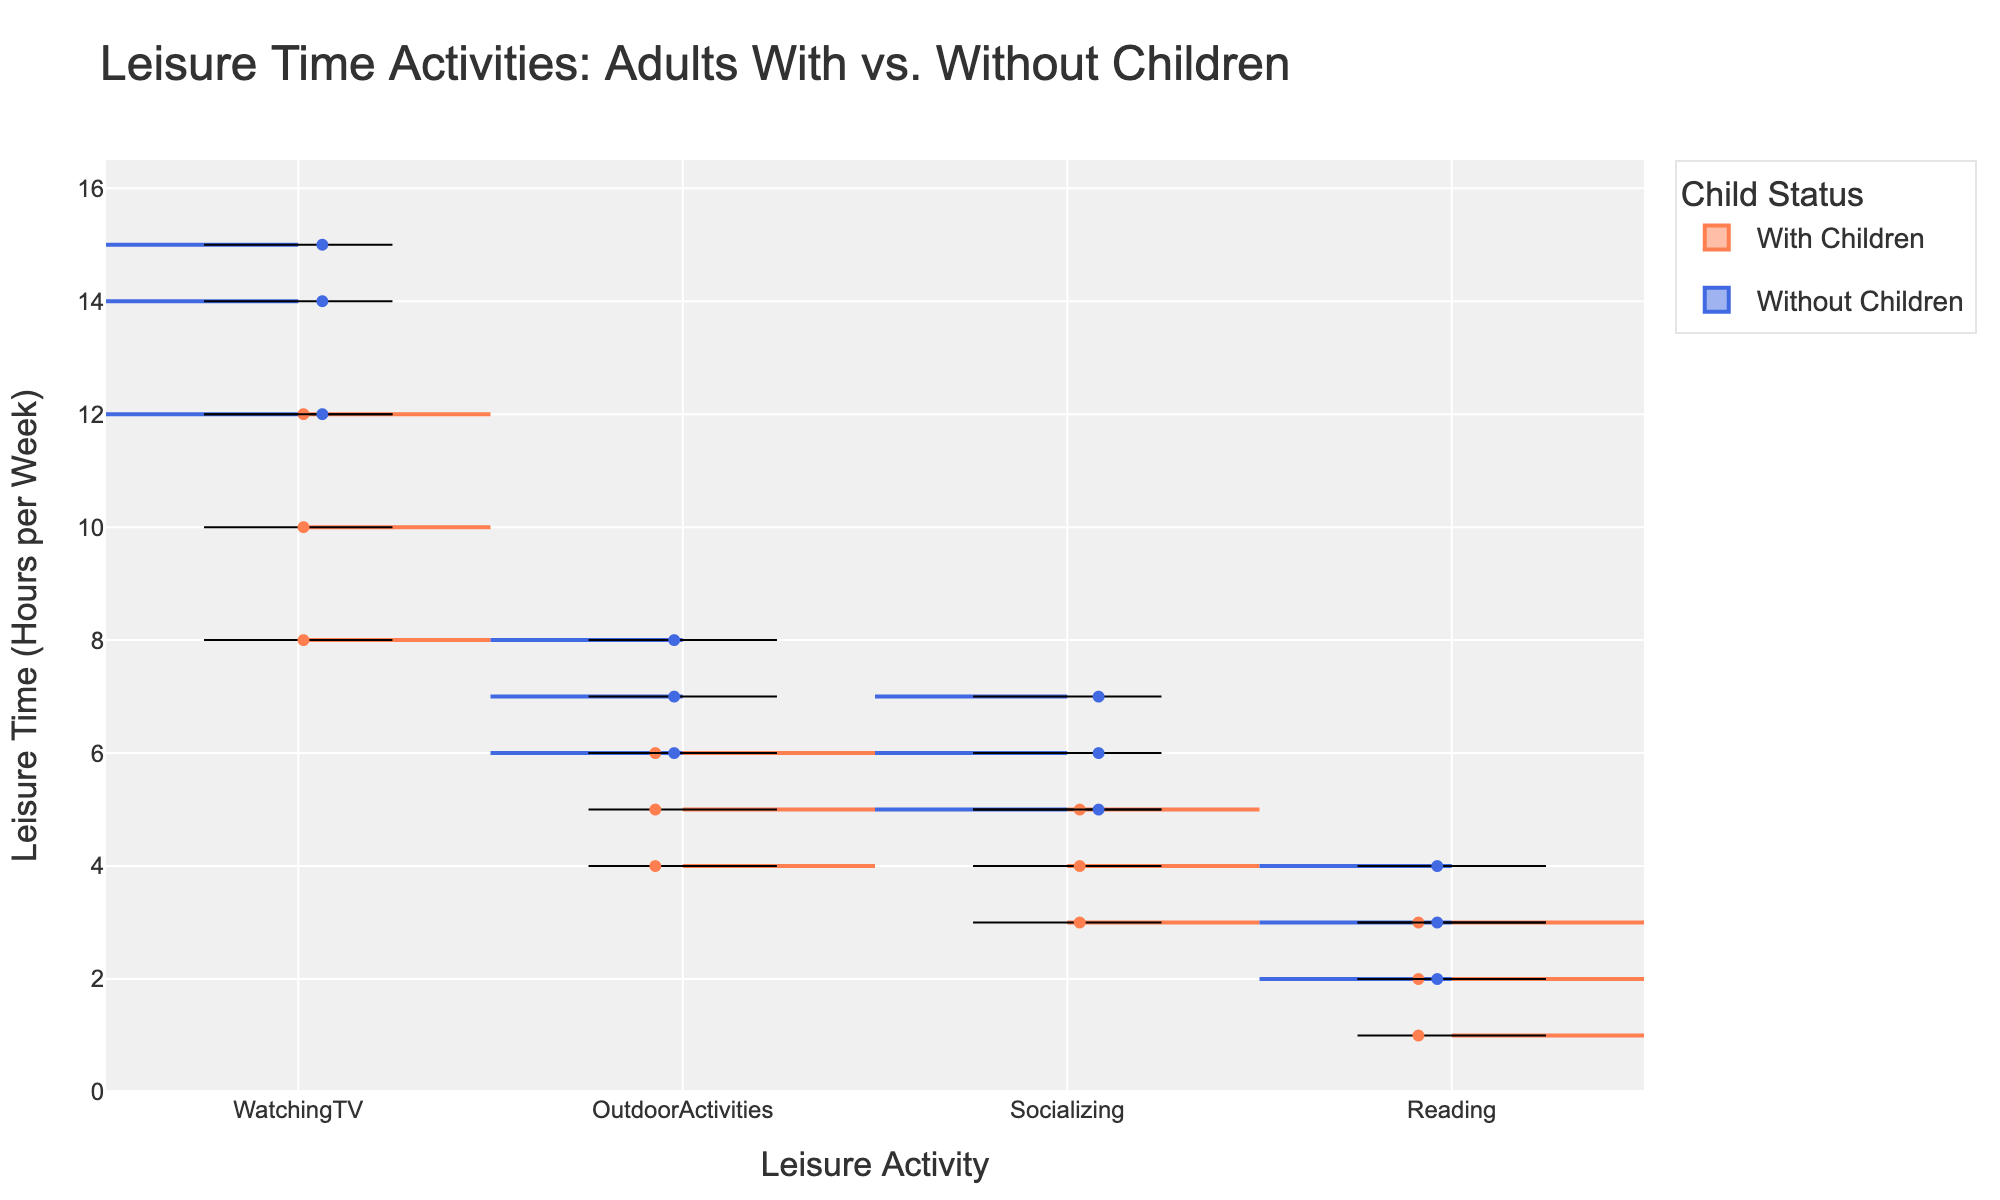What's the title of the figure? The title is clearly displayed at the top of the figure, usually in a larger and bold font. It sets the context or subject of the visual representation.
Answer: Leisure Time Activities: Adults With vs. Without Children What is the y-axis representing? The y-axis label indicates what the vertical scale represents in the figure. Here, it specifies the measured units in the dataset.
Answer: Leisure Time (Hours per Week) How many leisure activities are compared in the figure? By counting the distinct categories along the x-axis, we can determine the number of different leisure activities covered in the figure.
Answer: Four Which group tends to spend more hours on watching TV in the low-income level: Adults with children or without children? By examining the position and spread of the violins and box plots for "WatchingTV" under the low-income category, we can compare the central tendency. The "Without Children" group shows higher median and longer whiskers.
Answer: Without children What leisure activity shows the smallest difference in average hours between adults with and without children at the high-income level? For the high-income level, compare the violins and box plots for each activity against each other to find the smallest difference. Both groups show similar patterns around “OutdoorActivities”.
Answer: Outdoor Activities Which group shows greater variance in reading time across all income levels? Analyzing the width and spread of the violin plots for "Reading" across different income levels for both groups will reveal which group has a broader distribution.
Answer: Without children What's the average leisure time spent on socializing for adults with children in the medium-income level? Locating the violin plot for "Socializing" within the medium-income level and analyzing any provided box plot or median line will give an estimated central tendency. The average is near the median given around 4 hours.
Answer: 4 hours Compare the median leisure time spent on outdoor activities across the different income levels for adults with children. Observe the thick central line within the violin plot (representing the median) for "OutdoorActivities" for each income level—Low, Medium, High—and compare these values.
Answer: Low: 4 hours, Medium: 5 hours, High: 6 hours Which group and income level combination reports the highest leisure time spent on reading? Look through the maximum values shown within the violin and box plot overlays for "Reading" across all combinations of child status and income levels to identify the highest. Adults without children in the high-income level show the highest hours reading (4 hours).
Answer: Without children, High-income level How does the variance in socializing among adults with children compare to those without children across income levels? Checking the spread of the violin plots for "Socializing" for every income level helps determine if there is a broader or narrower spread. Without children show more spread indicating higher variance.
Answer: Without children show greater variance 